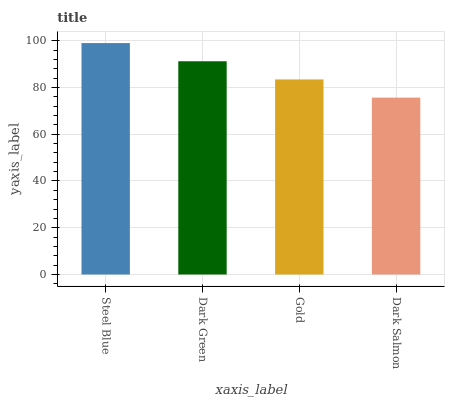Is Dark Green the minimum?
Answer yes or no. No. Is Dark Green the maximum?
Answer yes or no. No. Is Steel Blue greater than Dark Green?
Answer yes or no. Yes. Is Dark Green less than Steel Blue?
Answer yes or no. Yes. Is Dark Green greater than Steel Blue?
Answer yes or no. No. Is Steel Blue less than Dark Green?
Answer yes or no. No. Is Dark Green the high median?
Answer yes or no. Yes. Is Gold the low median?
Answer yes or no. Yes. Is Steel Blue the high median?
Answer yes or no. No. Is Dark Green the low median?
Answer yes or no. No. 